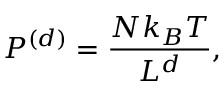<formula> <loc_0><loc_0><loc_500><loc_500>P ^ { ( d ) } = { \frac { N k _ { B } T } { L ^ { d } } } ,</formula> 